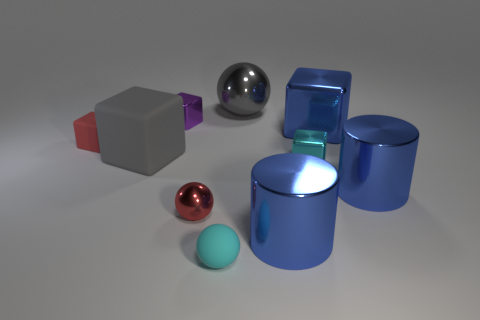How many cylinders are to the right of the cyan cube?
Give a very brief answer. 1. Is the material of the small thing that is on the left side of the gray block the same as the small purple block?
Provide a succinct answer. No. What is the color of the large shiny object that is the same shape as the big gray matte object?
Keep it short and to the point. Blue. The small purple metal object is what shape?
Give a very brief answer. Cube. What number of things are either small yellow metal objects or tiny rubber objects?
Your answer should be very brief. 2. There is a tiny ball that is on the right side of the red sphere; is its color the same as the metal block that is in front of the red rubber block?
Provide a short and direct response. Yes. What number of other things are the same shape as the gray rubber thing?
Your answer should be compact. 4. Is there a small blue metallic cylinder?
Provide a short and direct response. No. What number of objects are blue metal cylinders or gray objects that are right of the purple object?
Your answer should be compact. 3. There is a metallic thing that is in front of the red metal object; is it the same size as the cyan rubber thing?
Provide a short and direct response. No. 